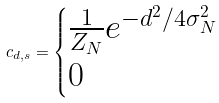Convert formula to latex. <formula><loc_0><loc_0><loc_500><loc_500>c _ { d , s } = \begin{cases} \frac { 1 } { Z _ { N } } e ^ { - d ^ { 2 } / 4 \sigma _ { N } ^ { 2 } } & \\ 0 & \end{cases}</formula> 